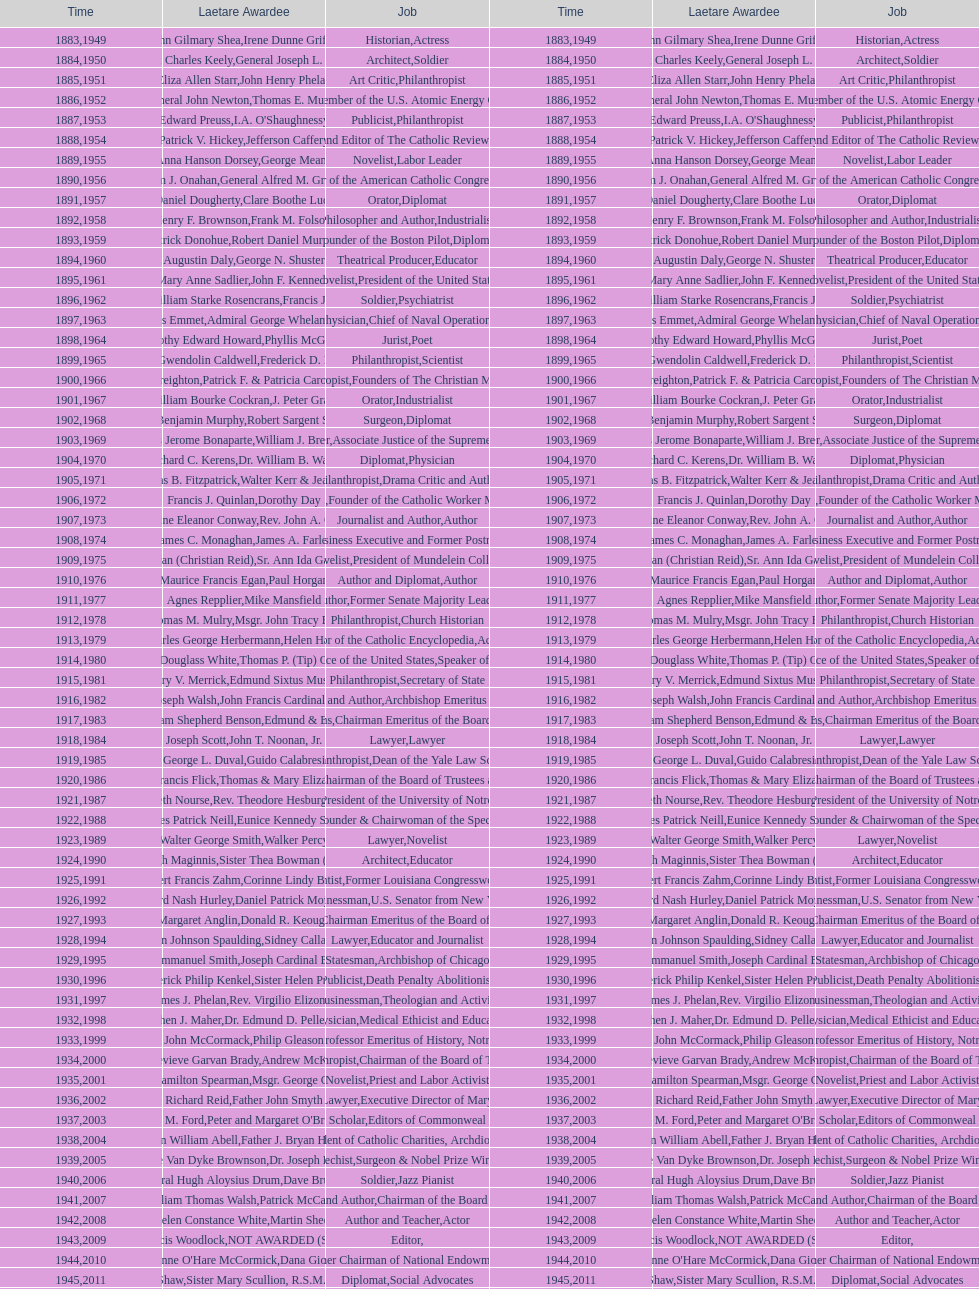How many are or were journalists? 5. 